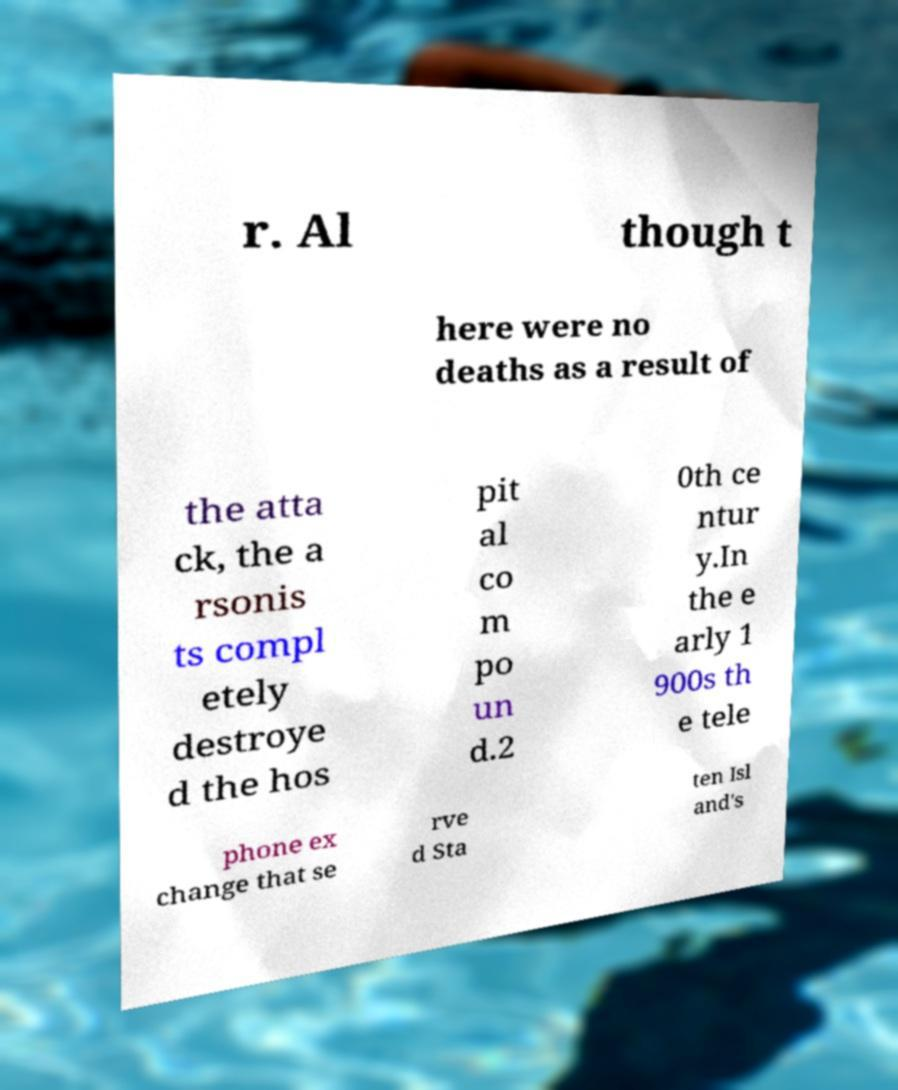I need the written content from this picture converted into text. Can you do that? r. Al though t here were no deaths as a result of the atta ck, the a rsonis ts compl etely destroye d the hos pit al co m po un d.2 0th ce ntur y.In the e arly 1 900s th e tele phone ex change that se rve d Sta ten Isl and's 